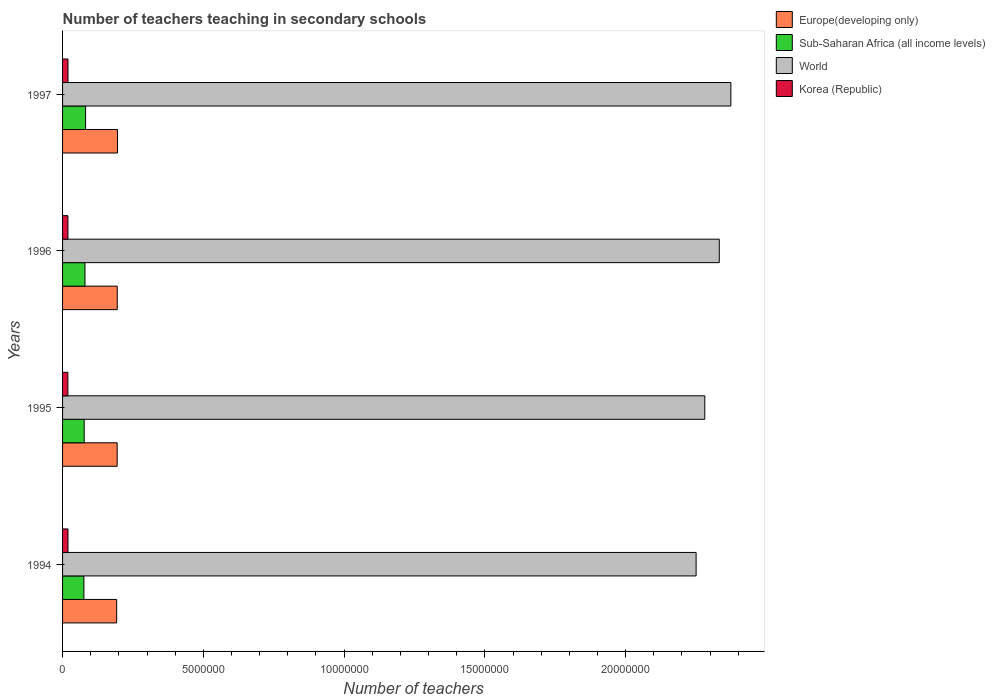How many different coloured bars are there?
Provide a short and direct response. 4. How many groups of bars are there?
Make the answer very short. 4. Are the number of bars on each tick of the Y-axis equal?
Provide a succinct answer. Yes. How many bars are there on the 2nd tick from the top?
Your answer should be compact. 4. What is the label of the 2nd group of bars from the top?
Offer a terse response. 1996. What is the number of teachers teaching in secondary schools in World in 1996?
Provide a succinct answer. 2.33e+07. Across all years, what is the maximum number of teachers teaching in secondary schools in Sub-Saharan Africa (all income levels)?
Offer a terse response. 8.17e+05. Across all years, what is the minimum number of teachers teaching in secondary schools in World?
Your answer should be compact. 2.25e+07. What is the total number of teachers teaching in secondary schools in Korea (Republic) in the graph?
Keep it short and to the point. 7.65e+05. What is the difference between the number of teachers teaching in secondary schools in Korea (Republic) in 1994 and that in 1995?
Keep it short and to the point. 3845. What is the difference between the number of teachers teaching in secondary schools in Sub-Saharan Africa (all income levels) in 1994 and the number of teachers teaching in secondary schools in Europe(developing only) in 1995?
Offer a very short reply. -1.18e+06. What is the average number of teachers teaching in secondary schools in World per year?
Your response must be concise. 2.31e+07. In the year 1997, what is the difference between the number of teachers teaching in secondary schools in Korea (Republic) and number of teachers teaching in secondary schools in Europe(developing only)?
Make the answer very short. -1.76e+06. What is the ratio of the number of teachers teaching in secondary schools in Sub-Saharan Africa (all income levels) in 1994 to that in 1995?
Provide a succinct answer. 0.99. Is the number of teachers teaching in secondary schools in Korea (Republic) in 1994 less than that in 1995?
Offer a very short reply. No. What is the difference between the highest and the second highest number of teachers teaching in secondary schools in Europe(developing only)?
Keep it short and to the point. 8324.12. What is the difference between the highest and the lowest number of teachers teaching in secondary schools in World?
Offer a very short reply. 1.23e+06. Is the sum of the number of teachers teaching in secondary schools in World in 1996 and 1997 greater than the maximum number of teachers teaching in secondary schools in Sub-Saharan Africa (all income levels) across all years?
Ensure brevity in your answer.  Yes. Is it the case that in every year, the sum of the number of teachers teaching in secondary schools in Sub-Saharan Africa (all income levels) and number of teachers teaching in secondary schools in Korea (Republic) is greater than the sum of number of teachers teaching in secondary schools in World and number of teachers teaching in secondary schools in Europe(developing only)?
Ensure brevity in your answer.  No. What does the 4th bar from the top in 1994 represents?
Keep it short and to the point. Europe(developing only). What does the 2nd bar from the bottom in 1994 represents?
Provide a short and direct response. Sub-Saharan Africa (all income levels). Is it the case that in every year, the sum of the number of teachers teaching in secondary schools in Korea (Republic) and number of teachers teaching in secondary schools in Sub-Saharan Africa (all income levels) is greater than the number of teachers teaching in secondary schools in World?
Give a very brief answer. No. How many years are there in the graph?
Provide a succinct answer. 4. What is the difference between two consecutive major ticks on the X-axis?
Keep it short and to the point. 5.00e+06. Are the values on the major ticks of X-axis written in scientific E-notation?
Your answer should be very brief. No. Does the graph contain any zero values?
Your answer should be very brief. No. Does the graph contain grids?
Provide a succinct answer. No. Where does the legend appear in the graph?
Give a very brief answer. Top right. How many legend labels are there?
Ensure brevity in your answer.  4. How are the legend labels stacked?
Offer a terse response. Vertical. What is the title of the graph?
Offer a very short reply. Number of teachers teaching in secondary schools. What is the label or title of the X-axis?
Keep it short and to the point. Number of teachers. What is the label or title of the Y-axis?
Your answer should be compact. Years. What is the Number of teachers in Europe(developing only) in 1994?
Provide a short and direct response. 1.92e+06. What is the Number of teachers in Sub-Saharan Africa (all income levels) in 1994?
Offer a very short reply. 7.58e+05. What is the Number of teachers of World in 1994?
Offer a very short reply. 2.25e+07. What is the Number of teachers in Korea (Republic) in 1994?
Offer a terse response. 1.93e+05. What is the Number of teachers of Europe(developing only) in 1995?
Your answer should be compact. 1.94e+06. What is the Number of teachers of Sub-Saharan Africa (all income levels) in 1995?
Keep it short and to the point. 7.68e+05. What is the Number of teachers in World in 1995?
Provide a short and direct response. 2.28e+07. What is the Number of teachers in Korea (Republic) in 1995?
Your response must be concise. 1.89e+05. What is the Number of teachers of Europe(developing only) in 1996?
Ensure brevity in your answer.  1.94e+06. What is the Number of teachers of Sub-Saharan Africa (all income levels) in 1996?
Offer a very short reply. 7.96e+05. What is the Number of teachers in World in 1996?
Your answer should be compact. 2.33e+07. What is the Number of teachers in Korea (Republic) in 1996?
Offer a terse response. 1.91e+05. What is the Number of teachers in Europe(developing only) in 1997?
Give a very brief answer. 1.95e+06. What is the Number of teachers in Sub-Saharan Africa (all income levels) in 1997?
Your response must be concise. 8.17e+05. What is the Number of teachers in World in 1997?
Give a very brief answer. 2.37e+07. What is the Number of teachers in Korea (Republic) in 1997?
Keep it short and to the point. 1.93e+05. Across all years, what is the maximum Number of teachers in Europe(developing only)?
Provide a short and direct response. 1.95e+06. Across all years, what is the maximum Number of teachers of Sub-Saharan Africa (all income levels)?
Provide a short and direct response. 8.17e+05. Across all years, what is the maximum Number of teachers in World?
Give a very brief answer. 2.37e+07. Across all years, what is the maximum Number of teachers of Korea (Republic)?
Offer a very short reply. 1.93e+05. Across all years, what is the minimum Number of teachers in Europe(developing only)?
Offer a very short reply. 1.92e+06. Across all years, what is the minimum Number of teachers of Sub-Saharan Africa (all income levels)?
Provide a succinct answer. 7.58e+05. Across all years, what is the minimum Number of teachers in World?
Your response must be concise. 2.25e+07. Across all years, what is the minimum Number of teachers of Korea (Republic)?
Keep it short and to the point. 1.89e+05. What is the total Number of teachers in Europe(developing only) in the graph?
Offer a terse response. 7.75e+06. What is the total Number of teachers in Sub-Saharan Africa (all income levels) in the graph?
Your answer should be very brief. 3.14e+06. What is the total Number of teachers in World in the graph?
Offer a terse response. 9.24e+07. What is the total Number of teachers in Korea (Republic) in the graph?
Your response must be concise. 7.65e+05. What is the difference between the Number of teachers in Europe(developing only) in 1994 and that in 1995?
Make the answer very short. -1.76e+04. What is the difference between the Number of teachers of Sub-Saharan Africa (all income levels) in 1994 and that in 1995?
Keep it short and to the point. -1.06e+04. What is the difference between the Number of teachers in World in 1994 and that in 1995?
Offer a terse response. -3.08e+05. What is the difference between the Number of teachers in Korea (Republic) in 1994 and that in 1995?
Ensure brevity in your answer.  3845. What is the difference between the Number of teachers in Europe(developing only) in 1994 and that in 1996?
Your response must be concise. -2.06e+04. What is the difference between the Number of teachers of Sub-Saharan Africa (all income levels) in 1994 and that in 1996?
Your answer should be very brief. -3.82e+04. What is the difference between the Number of teachers of World in 1994 and that in 1996?
Make the answer very short. -8.23e+05. What is the difference between the Number of teachers of Korea (Republic) in 1994 and that in 1996?
Make the answer very short. 2036. What is the difference between the Number of teachers of Europe(developing only) in 1994 and that in 1997?
Give a very brief answer. -2.89e+04. What is the difference between the Number of teachers of Sub-Saharan Africa (all income levels) in 1994 and that in 1997?
Provide a succinct answer. -5.96e+04. What is the difference between the Number of teachers of World in 1994 and that in 1997?
Your answer should be compact. -1.23e+06. What is the difference between the Number of teachers in Korea (Republic) in 1994 and that in 1997?
Ensure brevity in your answer.  -244. What is the difference between the Number of teachers in Europe(developing only) in 1995 and that in 1996?
Give a very brief answer. -2974.62. What is the difference between the Number of teachers of Sub-Saharan Africa (all income levels) in 1995 and that in 1996?
Your answer should be compact. -2.75e+04. What is the difference between the Number of teachers of World in 1995 and that in 1996?
Ensure brevity in your answer.  -5.15e+05. What is the difference between the Number of teachers of Korea (Republic) in 1995 and that in 1996?
Your answer should be compact. -1809. What is the difference between the Number of teachers in Europe(developing only) in 1995 and that in 1997?
Give a very brief answer. -1.13e+04. What is the difference between the Number of teachers in Sub-Saharan Africa (all income levels) in 1995 and that in 1997?
Give a very brief answer. -4.90e+04. What is the difference between the Number of teachers in World in 1995 and that in 1997?
Offer a very short reply. -9.26e+05. What is the difference between the Number of teachers of Korea (Republic) in 1995 and that in 1997?
Make the answer very short. -4089. What is the difference between the Number of teachers in Europe(developing only) in 1996 and that in 1997?
Offer a terse response. -8324.12. What is the difference between the Number of teachers of Sub-Saharan Africa (all income levels) in 1996 and that in 1997?
Provide a succinct answer. -2.14e+04. What is the difference between the Number of teachers in World in 1996 and that in 1997?
Make the answer very short. -4.12e+05. What is the difference between the Number of teachers of Korea (Republic) in 1996 and that in 1997?
Keep it short and to the point. -2280. What is the difference between the Number of teachers in Europe(developing only) in 1994 and the Number of teachers in Sub-Saharan Africa (all income levels) in 1995?
Make the answer very short. 1.15e+06. What is the difference between the Number of teachers of Europe(developing only) in 1994 and the Number of teachers of World in 1995?
Offer a very short reply. -2.09e+07. What is the difference between the Number of teachers of Europe(developing only) in 1994 and the Number of teachers of Korea (Republic) in 1995?
Ensure brevity in your answer.  1.73e+06. What is the difference between the Number of teachers in Sub-Saharan Africa (all income levels) in 1994 and the Number of teachers in World in 1995?
Your response must be concise. -2.21e+07. What is the difference between the Number of teachers of Sub-Saharan Africa (all income levels) in 1994 and the Number of teachers of Korea (Republic) in 1995?
Ensure brevity in your answer.  5.69e+05. What is the difference between the Number of teachers of World in 1994 and the Number of teachers of Korea (Republic) in 1995?
Keep it short and to the point. 2.23e+07. What is the difference between the Number of teachers in Europe(developing only) in 1994 and the Number of teachers in Sub-Saharan Africa (all income levels) in 1996?
Give a very brief answer. 1.13e+06. What is the difference between the Number of teachers of Europe(developing only) in 1994 and the Number of teachers of World in 1996?
Your answer should be compact. -2.14e+07. What is the difference between the Number of teachers in Europe(developing only) in 1994 and the Number of teachers in Korea (Republic) in 1996?
Your response must be concise. 1.73e+06. What is the difference between the Number of teachers of Sub-Saharan Africa (all income levels) in 1994 and the Number of teachers of World in 1996?
Make the answer very short. -2.26e+07. What is the difference between the Number of teachers of Sub-Saharan Africa (all income levels) in 1994 and the Number of teachers of Korea (Republic) in 1996?
Ensure brevity in your answer.  5.67e+05. What is the difference between the Number of teachers of World in 1994 and the Number of teachers of Korea (Republic) in 1996?
Offer a terse response. 2.23e+07. What is the difference between the Number of teachers in Europe(developing only) in 1994 and the Number of teachers in Sub-Saharan Africa (all income levels) in 1997?
Your answer should be very brief. 1.10e+06. What is the difference between the Number of teachers of Europe(developing only) in 1994 and the Number of teachers of World in 1997?
Give a very brief answer. -2.18e+07. What is the difference between the Number of teachers of Europe(developing only) in 1994 and the Number of teachers of Korea (Republic) in 1997?
Give a very brief answer. 1.73e+06. What is the difference between the Number of teachers in Sub-Saharan Africa (all income levels) in 1994 and the Number of teachers in World in 1997?
Ensure brevity in your answer.  -2.30e+07. What is the difference between the Number of teachers in Sub-Saharan Africa (all income levels) in 1994 and the Number of teachers in Korea (Republic) in 1997?
Ensure brevity in your answer.  5.65e+05. What is the difference between the Number of teachers of World in 1994 and the Number of teachers of Korea (Republic) in 1997?
Offer a terse response. 2.23e+07. What is the difference between the Number of teachers in Europe(developing only) in 1995 and the Number of teachers in Sub-Saharan Africa (all income levels) in 1996?
Ensure brevity in your answer.  1.14e+06. What is the difference between the Number of teachers of Europe(developing only) in 1995 and the Number of teachers of World in 1996?
Make the answer very short. -2.14e+07. What is the difference between the Number of teachers of Europe(developing only) in 1995 and the Number of teachers of Korea (Republic) in 1996?
Offer a terse response. 1.75e+06. What is the difference between the Number of teachers in Sub-Saharan Africa (all income levels) in 1995 and the Number of teachers in World in 1996?
Make the answer very short. -2.26e+07. What is the difference between the Number of teachers in Sub-Saharan Africa (all income levels) in 1995 and the Number of teachers in Korea (Republic) in 1996?
Your answer should be compact. 5.78e+05. What is the difference between the Number of teachers in World in 1995 and the Number of teachers in Korea (Republic) in 1996?
Provide a short and direct response. 2.26e+07. What is the difference between the Number of teachers of Europe(developing only) in 1995 and the Number of teachers of Sub-Saharan Africa (all income levels) in 1997?
Give a very brief answer. 1.12e+06. What is the difference between the Number of teachers of Europe(developing only) in 1995 and the Number of teachers of World in 1997?
Your answer should be compact. -2.18e+07. What is the difference between the Number of teachers in Europe(developing only) in 1995 and the Number of teachers in Korea (Republic) in 1997?
Your answer should be compact. 1.75e+06. What is the difference between the Number of teachers in Sub-Saharan Africa (all income levels) in 1995 and the Number of teachers in World in 1997?
Provide a short and direct response. -2.30e+07. What is the difference between the Number of teachers in Sub-Saharan Africa (all income levels) in 1995 and the Number of teachers in Korea (Republic) in 1997?
Your response must be concise. 5.75e+05. What is the difference between the Number of teachers in World in 1995 and the Number of teachers in Korea (Republic) in 1997?
Your response must be concise. 2.26e+07. What is the difference between the Number of teachers in Europe(developing only) in 1996 and the Number of teachers in Sub-Saharan Africa (all income levels) in 1997?
Offer a very short reply. 1.13e+06. What is the difference between the Number of teachers of Europe(developing only) in 1996 and the Number of teachers of World in 1997?
Ensure brevity in your answer.  -2.18e+07. What is the difference between the Number of teachers in Europe(developing only) in 1996 and the Number of teachers in Korea (Republic) in 1997?
Your answer should be very brief. 1.75e+06. What is the difference between the Number of teachers of Sub-Saharan Africa (all income levels) in 1996 and the Number of teachers of World in 1997?
Make the answer very short. -2.29e+07. What is the difference between the Number of teachers in Sub-Saharan Africa (all income levels) in 1996 and the Number of teachers in Korea (Republic) in 1997?
Your answer should be very brief. 6.03e+05. What is the difference between the Number of teachers in World in 1996 and the Number of teachers in Korea (Republic) in 1997?
Ensure brevity in your answer.  2.31e+07. What is the average Number of teachers of Europe(developing only) per year?
Make the answer very short. 1.94e+06. What is the average Number of teachers of Sub-Saharan Africa (all income levels) per year?
Your answer should be compact. 7.85e+05. What is the average Number of teachers of World per year?
Offer a terse response. 2.31e+07. What is the average Number of teachers of Korea (Republic) per year?
Ensure brevity in your answer.  1.91e+05. In the year 1994, what is the difference between the Number of teachers of Europe(developing only) and Number of teachers of Sub-Saharan Africa (all income levels)?
Provide a succinct answer. 1.16e+06. In the year 1994, what is the difference between the Number of teachers in Europe(developing only) and Number of teachers in World?
Offer a terse response. -2.06e+07. In the year 1994, what is the difference between the Number of teachers in Europe(developing only) and Number of teachers in Korea (Republic)?
Your answer should be compact. 1.73e+06. In the year 1994, what is the difference between the Number of teachers of Sub-Saharan Africa (all income levels) and Number of teachers of World?
Offer a very short reply. -2.17e+07. In the year 1994, what is the difference between the Number of teachers of Sub-Saharan Africa (all income levels) and Number of teachers of Korea (Republic)?
Offer a very short reply. 5.65e+05. In the year 1994, what is the difference between the Number of teachers in World and Number of teachers in Korea (Republic)?
Your answer should be very brief. 2.23e+07. In the year 1995, what is the difference between the Number of teachers in Europe(developing only) and Number of teachers in Sub-Saharan Africa (all income levels)?
Keep it short and to the point. 1.17e+06. In the year 1995, what is the difference between the Number of teachers in Europe(developing only) and Number of teachers in World?
Your answer should be very brief. -2.09e+07. In the year 1995, what is the difference between the Number of teachers of Europe(developing only) and Number of teachers of Korea (Republic)?
Offer a very short reply. 1.75e+06. In the year 1995, what is the difference between the Number of teachers in Sub-Saharan Africa (all income levels) and Number of teachers in World?
Your response must be concise. -2.20e+07. In the year 1995, what is the difference between the Number of teachers in Sub-Saharan Africa (all income levels) and Number of teachers in Korea (Republic)?
Your answer should be compact. 5.79e+05. In the year 1995, what is the difference between the Number of teachers of World and Number of teachers of Korea (Republic)?
Keep it short and to the point. 2.26e+07. In the year 1996, what is the difference between the Number of teachers in Europe(developing only) and Number of teachers in Sub-Saharan Africa (all income levels)?
Make the answer very short. 1.15e+06. In the year 1996, what is the difference between the Number of teachers of Europe(developing only) and Number of teachers of World?
Your answer should be compact. -2.14e+07. In the year 1996, what is the difference between the Number of teachers of Europe(developing only) and Number of teachers of Korea (Republic)?
Ensure brevity in your answer.  1.75e+06. In the year 1996, what is the difference between the Number of teachers of Sub-Saharan Africa (all income levels) and Number of teachers of World?
Ensure brevity in your answer.  -2.25e+07. In the year 1996, what is the difference between the Number of teachers in Sub-Saharan Africa (all income levels) and Number of teachers in Korea (Republic)?
Keep it short and to the point. 6.05e+05. In the year 1996, what is the difference between the Number of teachers in World and Number of teachers in Korea (Republic)?
Provide a short and direct response. 2.31e+07. In the year 1997, what is the difference between the Number of teachers of Europe(developing only) and Number of teachers of Sub-Saharan Africa (all income levels)?
Ensure brevity in your answer.  1.13e+06. In the year 1997, what is the difference between the Number of teachers in Europe(developing only) and Number of teachers in World?
Give a very brief answer. -2.18e+07. In the year 1997, what is the difference between the Number of teachers in Europe(developing only) and Number of teachers in Korea (Republic)?
Keep it short and to the point. 1.76e+06. In the year 1997, what is the difference between the Number of teachers in Sub-Saharan Africa (all income levels) and Number of teachers in World?
Your response must be concise. -2.29e+07. In the year 1997, what is the difference between the Number of teachers of Sub-Saharan Africa (all income levels) and Number of teachers of Korea (Republic)?
Your response must be concise. 6.24e+05. In the year 1997, what is the difference between the Number of teachers of World and Number of teachers of Korea (Republic)?
Ensure brevity in your answer.  2.35e+07. What is the ratio of the Number of teachers in Europe(developing only) in 1994 to that in 1995?
Provide a succinct answer. 0.99. What is the ratio of the Number of teachers in Sub-Saharan Africa (all income levels) in 1994 to that in 1995?
Keep it short and to the point. 0.99. What is the ratio of the Number of teachers of World in 1994 to that in 1995?
Your answer should be compact. 0.99. What is the ratio of the Number of teachers in Korea (Republic) in 1994 to that in 1995?
Provide a short and direct response. 1.02. What is the ratio of the Number of teachers of World in 1994 to that in 1996?
Keep it short and to the point. 0.96. What is the ratio of the Number of teachers of Korea (Republic) in 1994 to that in 1996?
Keep it short and to the point. 1.01. What is the ratio of the Number of teachers of Europe(developing only) in 1994 to that in 1997?
Your answer should be compact. 0.99. What is the ratio of the Number of teachers of Sub-Saharan Africa (all income levels) in 1994 to that in 1997?
Your answer should be very brief. 0.93. What is the ratio of the Number of teachers in World in 1994 to that in 1997?
Offer a terse response. 0.95. What is the ratio of the Number of teachers of Sub-Saharan Africa (all income levels) in 1995 to that in 1996?
Your response must be concise. 0.97. What is the ratio of the Number of teachers in World in 1995 to that in 1996?
Provide a succinct answer. 0.98. What is the ratio of the Number of teachers of Korea (Republic) in 1995 to that in 1996?
Your answer should be compact. 0.99. What is the ratio of the Number of teachers in Sub-Saharan Africa (all income levels) in 1995 to that in 1997?
Provide a succinct answer. 0.94. What is the ratio of the Number of teachers in Korea (Republic) in 1995 to that in 1997?
Keep it short and to the point. 0.98. What is the ratio of the Number of teachers in Europe(developing only) in 1996 to that in 1997?
Provide a succinct answer. 1. What is the ratio of the Number of teachers in Sub-Saharan Africa (all income levels) in 1996 to that in 1997?
Offer a very short reply. 0.97. What is the ratio of the Number of teachers of World in 1996 to that in 1997?
Provide a succinct answer. 0.98. What is the difference between the highest and the second highest Number of teachers of Europe(developing only)?
Your response must be concise. 8324.12. What is the difference between the highest and the second highest Number of teachers of Sub-Saharan Africa (all income levels)?
Provide a succinct answer. 2.14e+04. What is the difference between the highest and the second highest Number of teachers in World?
Provide a succinct answer. 4.12e+05. What is the difference between the highest and the second highest Number of teachers of Korea (Republic)?
Provide a short and direct response. 244. What is the difference between the highest and the lowest Number of teachers in Europe(developing only)?
Your answer should be compact. 2.89e+04. What is the difference between the highest and the lowest Number of teachers of Sub-Saharan Africa (all income levels)?
Give a very brief answer. 5.96e+04. What is the difference between the highest and the lowest Number of teachers in World?
Offer a terse response. 1.23e+06. What is the difference between the highest and the lowest Number of teachers of Korea (Republic)?
Give a very brief answer. 4089. 